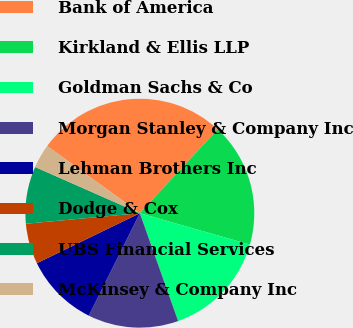Convert chart to OTSL. <chart><loc_0><loc_0><loc_500><loc_500><pie_chart><fcel>Bank of America<fcel>Kirkland & Ellis LLP<fcel>Goldman Sachs & Co<fcel>Morgan Stanley & Company Inc<fcel>Lehman Brothers Inc<fcel>Dodge & Cox<fcel>UBS Financial Services<fcel>McKinsey & Company Inc<nl><fcel>26.93%<fcel>17.51%<fcel>15.15%<fcel>12.79%<fcel>10.44%<fcel>5.73%<fcel>8.08%<fcel>3.37%<nl></chart> 